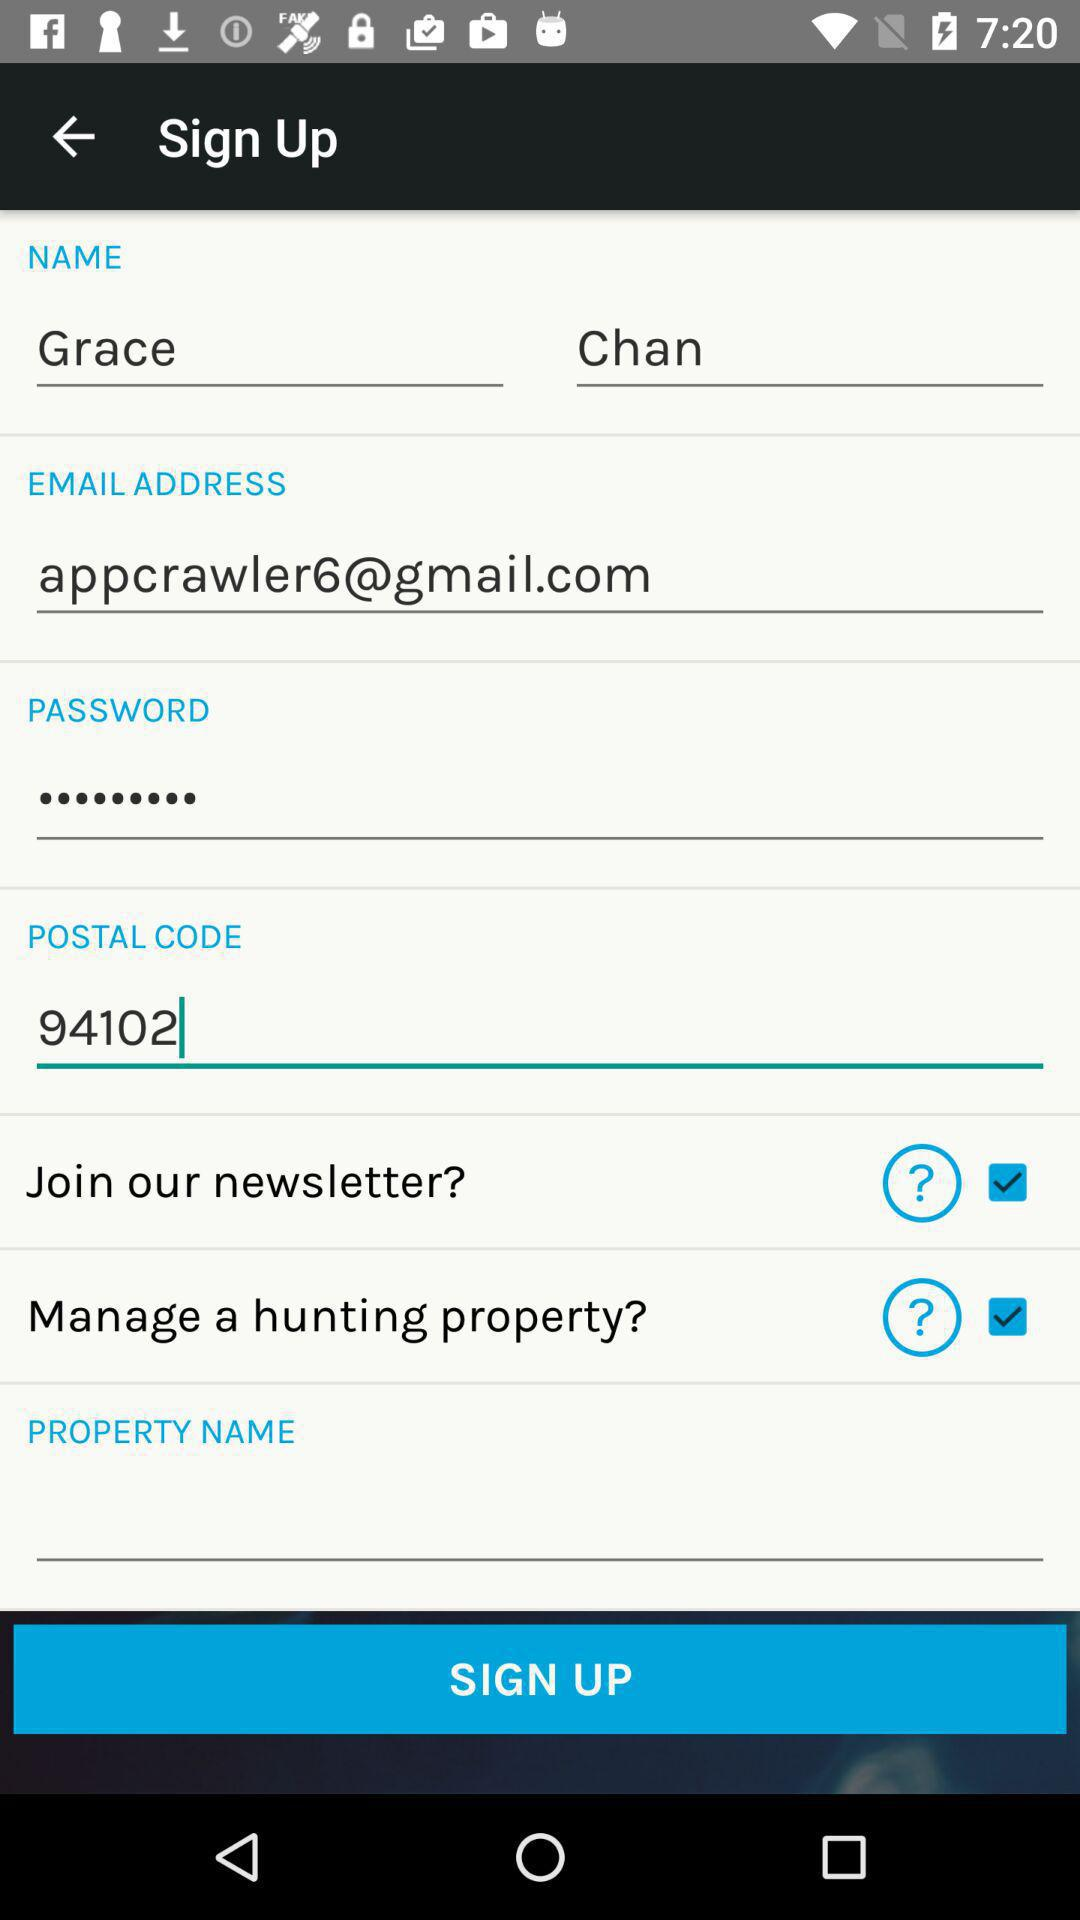What is the email address of the user? The email address of the user is appcrawler6@gmail.com. 